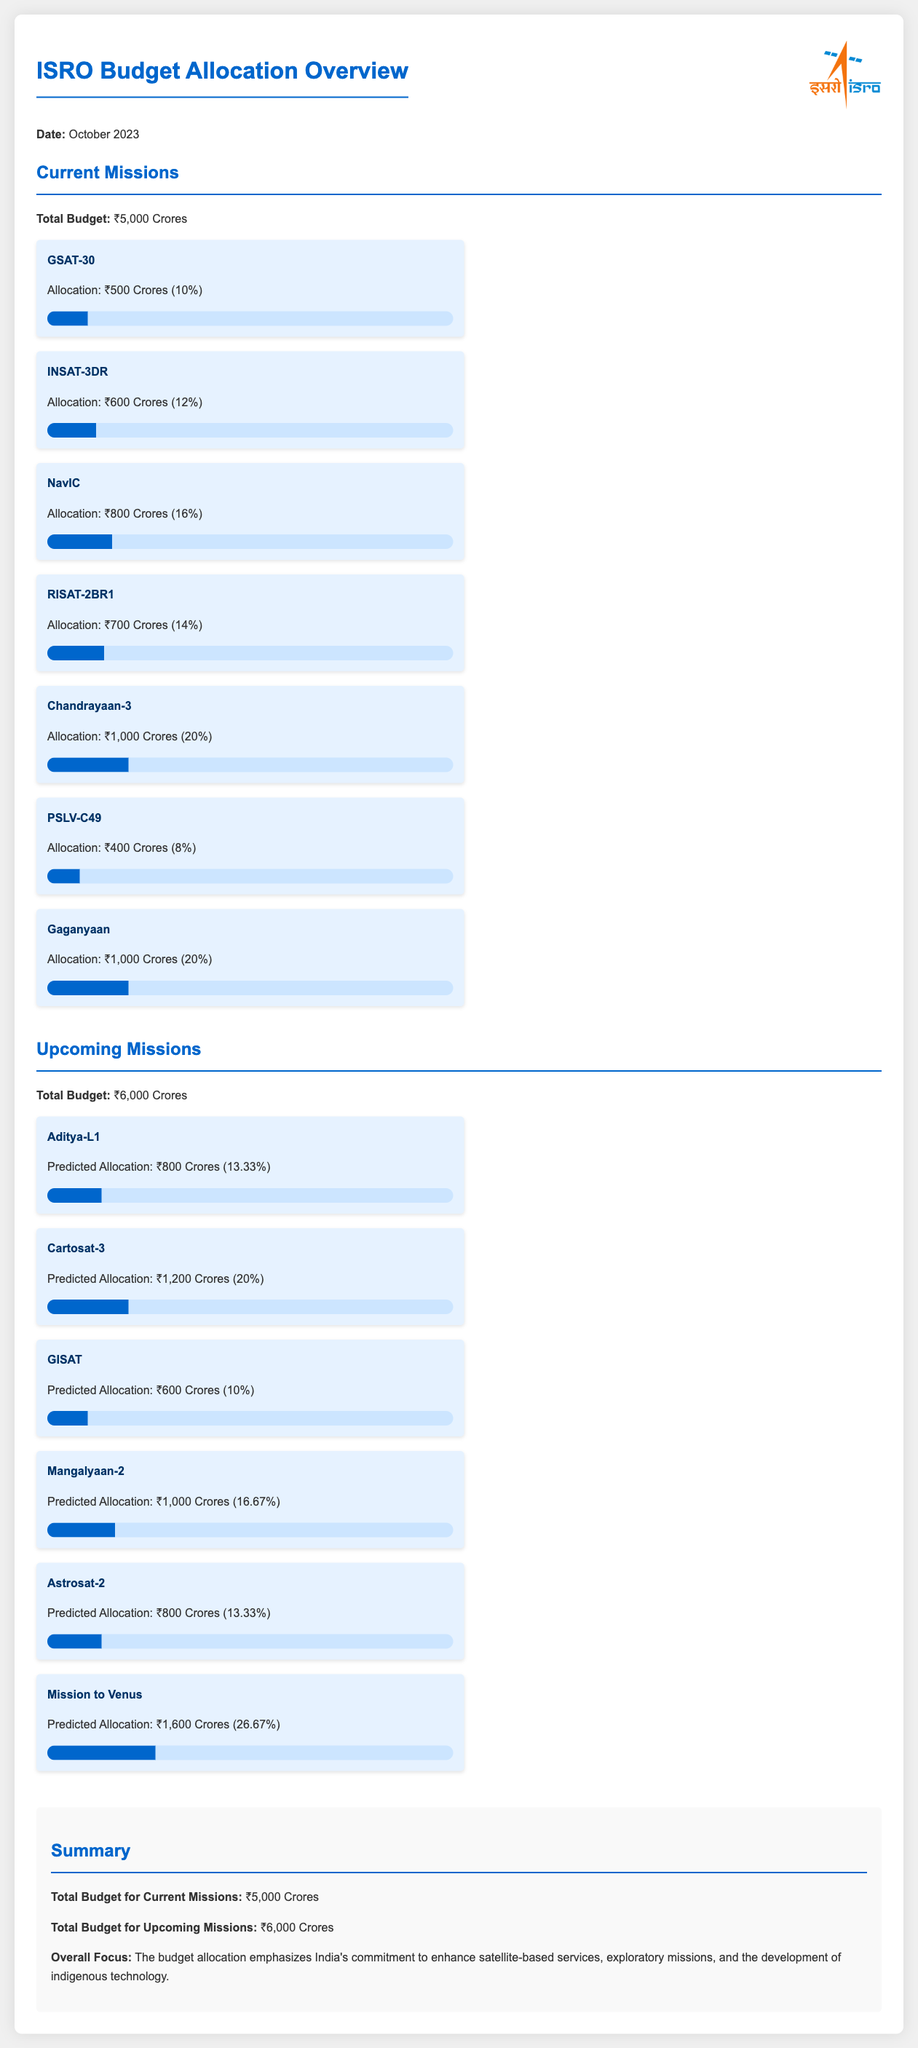What is the total budget for current missions? The total budget for current missions is stated in the document under the "Current Missions" section as ₹5,000 Crores.
Answer: ₹5,000 Crores What percentage of the budget is allocated to Chandrayaan-3? The allocation for Chandrayaan-3 is specifically noted in the document, which states it is ₹1,000 Crores, constituting 20% of the total current missions' budget.
Answer: 20% How much is the predicted allocation for Mission to Venus? The document provides the predicted allocation for the Mission to Venus as ₹1,600 Crores (26.67%).
Answer: ₹1,600 Crores Which mission has the highest budget allocation in upcoming missions? The document lists the budget allocations for upcoming missions, identifying Mission to Venus with an allocation of ₹1,600 Crores as the highest.
Answer: Mission to Venus What is the total budget for upcoming missions? The total budget for upcoming missions is explicitly stated in the document as ₹6,000 Crores.
Answer: ₹6,000 Crores How much is allocated for Gaganyaan? The document details the allocation for Gaganyaan as ₹1,000 Crores, clearly listing it under current missions.
Answer: ₹1,000 Crores What percentage of the budget is allocated to GISAT? The document specifies the allocation for GISAT as ₹600 Crores, which corresponds to 10% of the current missions' budget.
Answer: 10% What does the budget overview emphasize regarding focus? The summary section concludes with a statement emphasizing the commitment to enhance satellite-based services, exploratory missions, and the development of indigenous technology.
Answer: Enhance satellite-based services How many missions are listed under current missions? The document details seven missions under the current missions section.
Answer: Seven missions What is the predicted allocation percentage for Astrosat-2? The predicted allocation for Astrosat-2 is listed as ₹800 Crores (13.33%) in the upcoming missions section of the document.
Answer: 13.33% 